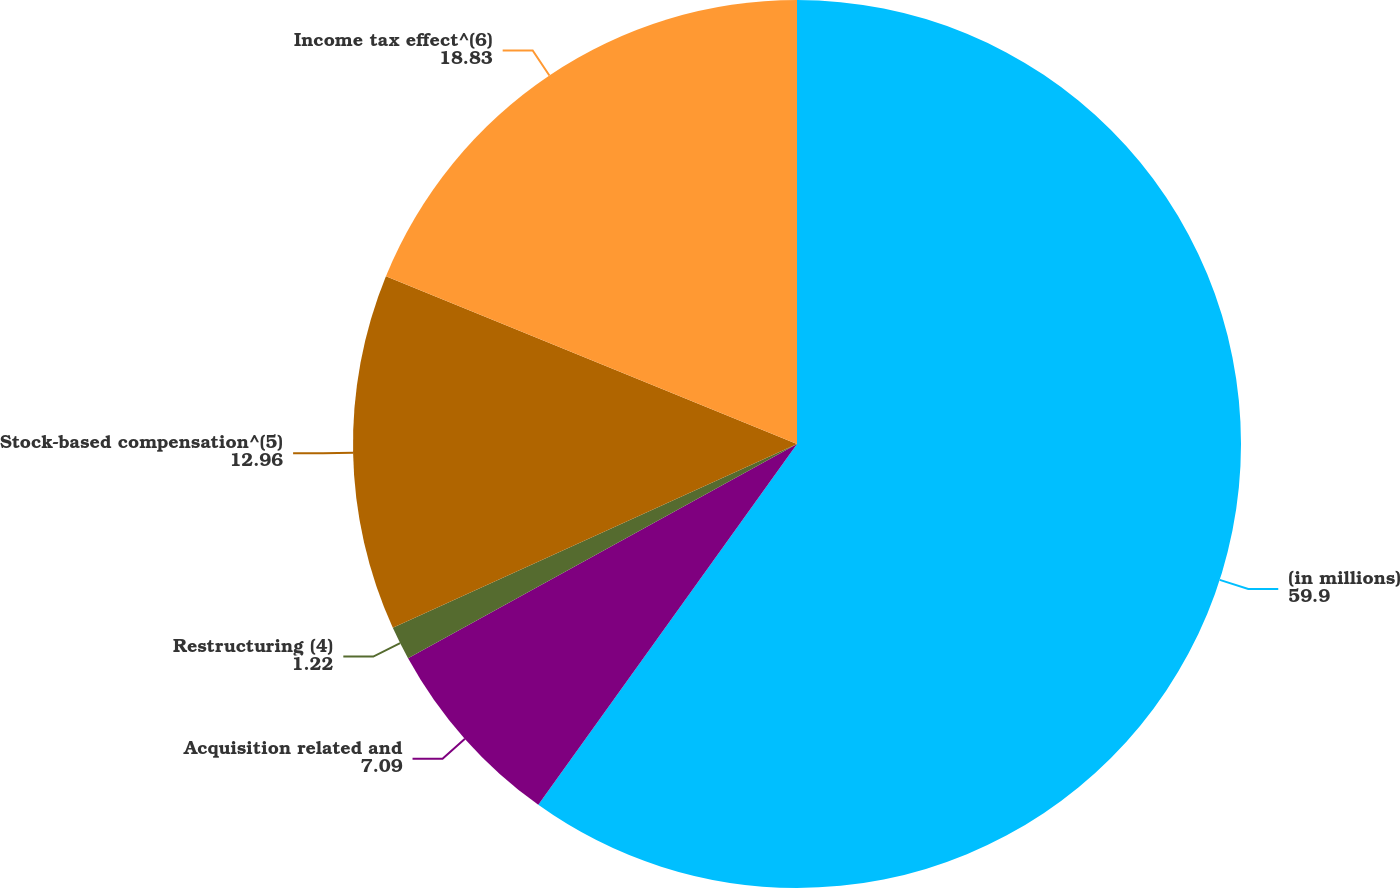Convert chart. <chart><loc_0><loc_0><loc_500><loc_500><pie_chart><fcel>(in millions)<fcel>Acquisition related and<fcel>Restructuring (4)<fcel>Stock-based compensation^(5)<fcel>Income tax effect^(6)<nl><fcel>59.9%<fcel>7.09%<fcel>1.22%<fcel>12.96%<fcel>18.83%<nl></chart> 